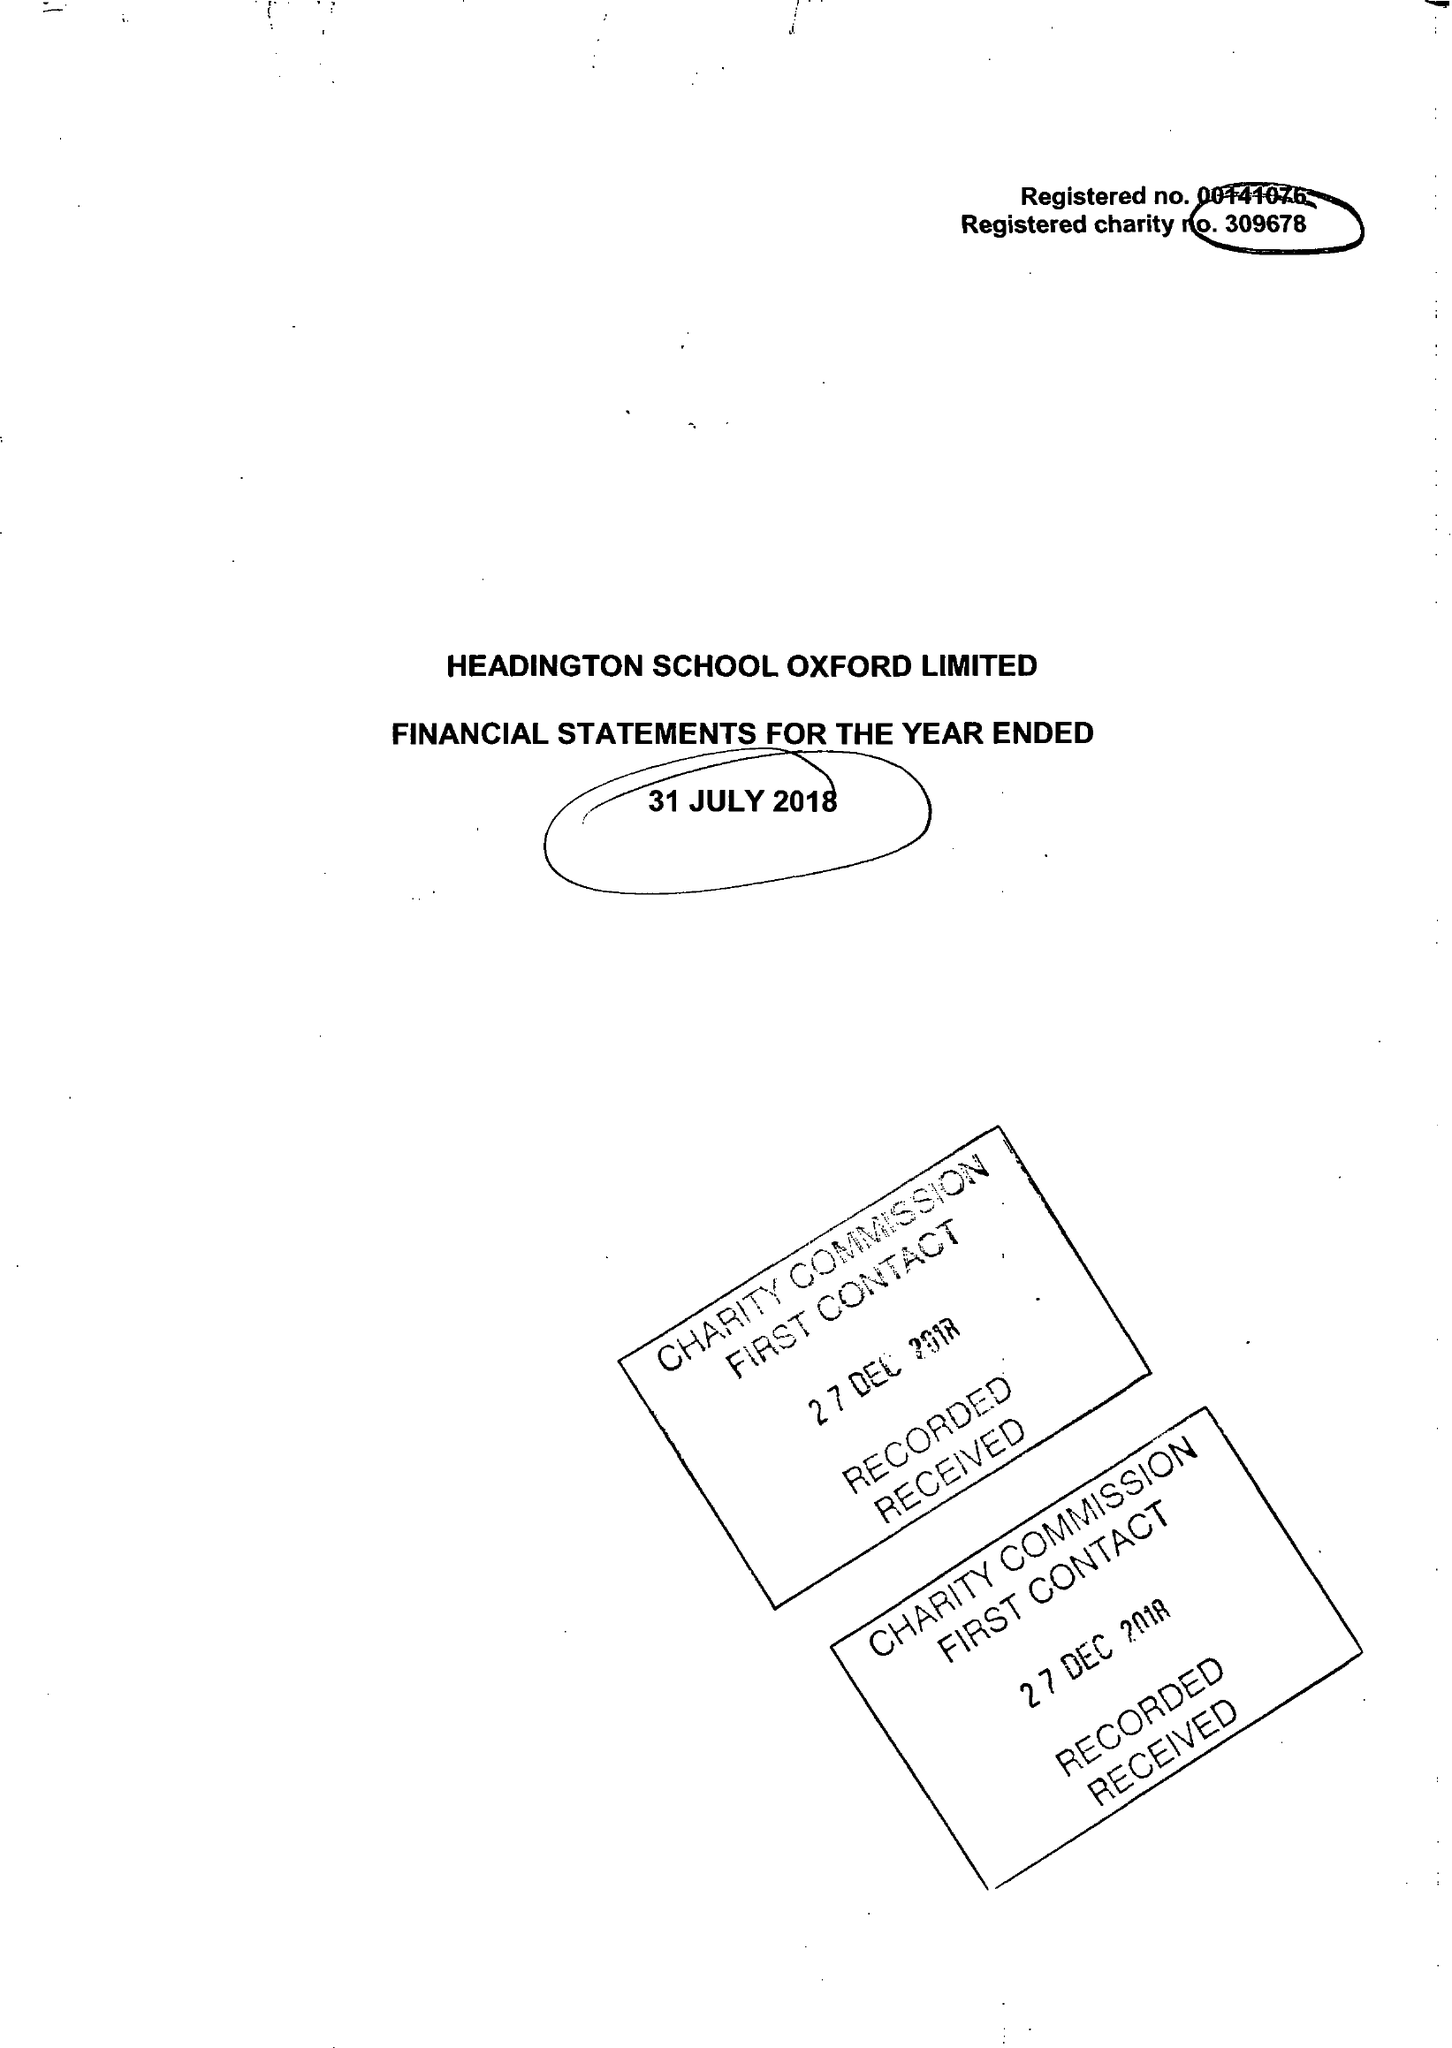What is the value for the charity_name?
Answer the question using a single word or phrase. Headington School Oxford Ltd. 